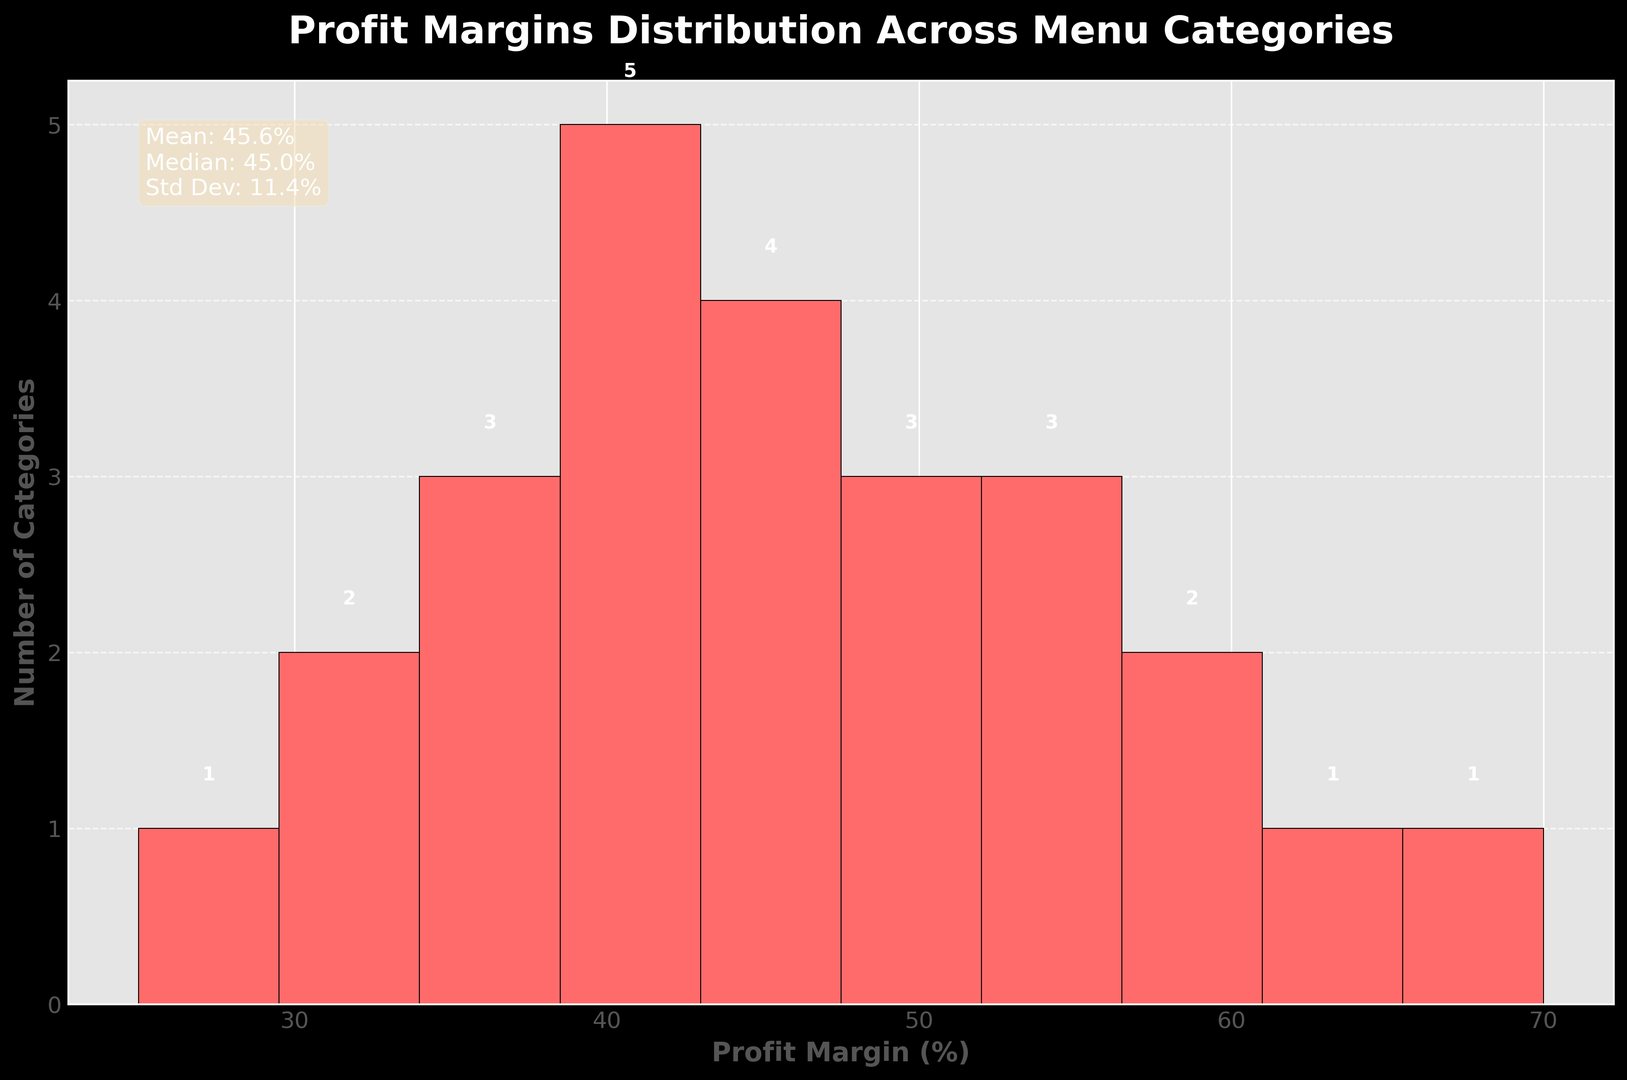What's the mean profit margin percentage? The mean is provided in the statistics text box on the figure. It states "Mean: 45.4%".
Answer: 45.4% Which category has the highest profit margin? The highest profit margin can be visually identified by the tallest bar on the right end of the histogram. According to the text box, "Beverages" has the highest profit margin of 70%.
Answer: Beverages How many categories have a profit margin between 40% and 60%? From the histogram, count the bars within the range of 40% to 60%. The bars in this range represent the profit margins between 40% and 60%. There are two such bars.
Answer: 2 What is the median profit margin percentage? The median is provided in the statistics text box on the figure. It states "Median: 45.0%".
Answer: 45.0% How many categories fall into the 30%-40% profit margin range? By observing the height of the bars in the specified range (30%-40%), count the number of categories represented. There are three categories in this range.
Answer: 3 Which profit margin range has the most number of categories? The bar with the highest value (also with the number on top) represents the range with the most categories. During visual inspection, the bar in the 40%-50% range is the tallest.
Answer: 40%-50% What is the profit margin range for the majority of menu items? Based on the bar height, the profit margins for the majority of menu items seem to be in the 40%-50% range, which contains the most categories.
Answer: 40%-50% What is the standard deviation of profit margins? The standard deviation is provided in the statistics text box on the figure. It states "Std Dev: 12.2%".
Answer: 12.2% Compare the number of categories with profit margins higher than 60% to those less than 30%. By visual inspection, there are two categories with profit margins higher than 60% and two with profit margins less than 30%. Therefore, the amounts are equal.
Answer: Equal How does the profit margin distribution skew visually? By observing the histogram, the distribution of profit margins appears slightly right-skewed since more bars are concentrated on the higher end.
Answer: Right-skewed 